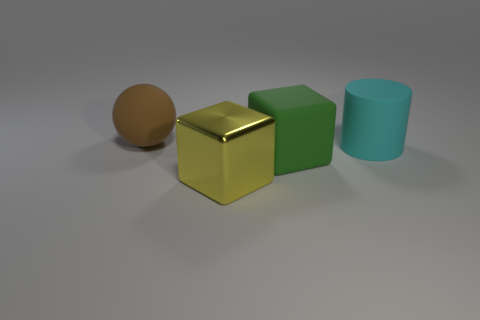Add 1 cyan rubber objects. How many objects exist? 5 Subtract all cylinders. How many objects are left? 3 Subtract 1 cyan cylinders. How many objects are left? 3 Subtract all rubber cubes. Subtract all cyan things. How many objects are left? 2 Add 2 shiny things. How many shiny things are left? 3 Add 2 large rubber blocks. How many large rubber blocks exist? 3 